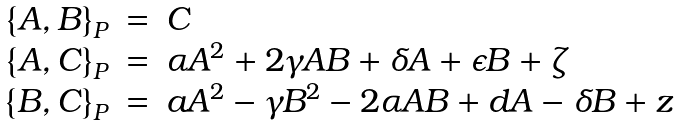<formula> <loc_0><loc_0><loc_500><loc_500>\begin{array} { r c l } \left \{ A , B \right \} _ { P } & = & C \\ \left \{ A , C \right \} _ { P } & = & \alpha A ^ { 2 } + 2 \gamma A B + \delta A + \epsilon B + \zeta \\ \left \{ B , C \right \} _ { P } & = & a A ^ { 2 } - \gamma B ^ { 2 } - 2 \alpha A B + d A - \delta B + z \end{array}</formula> 